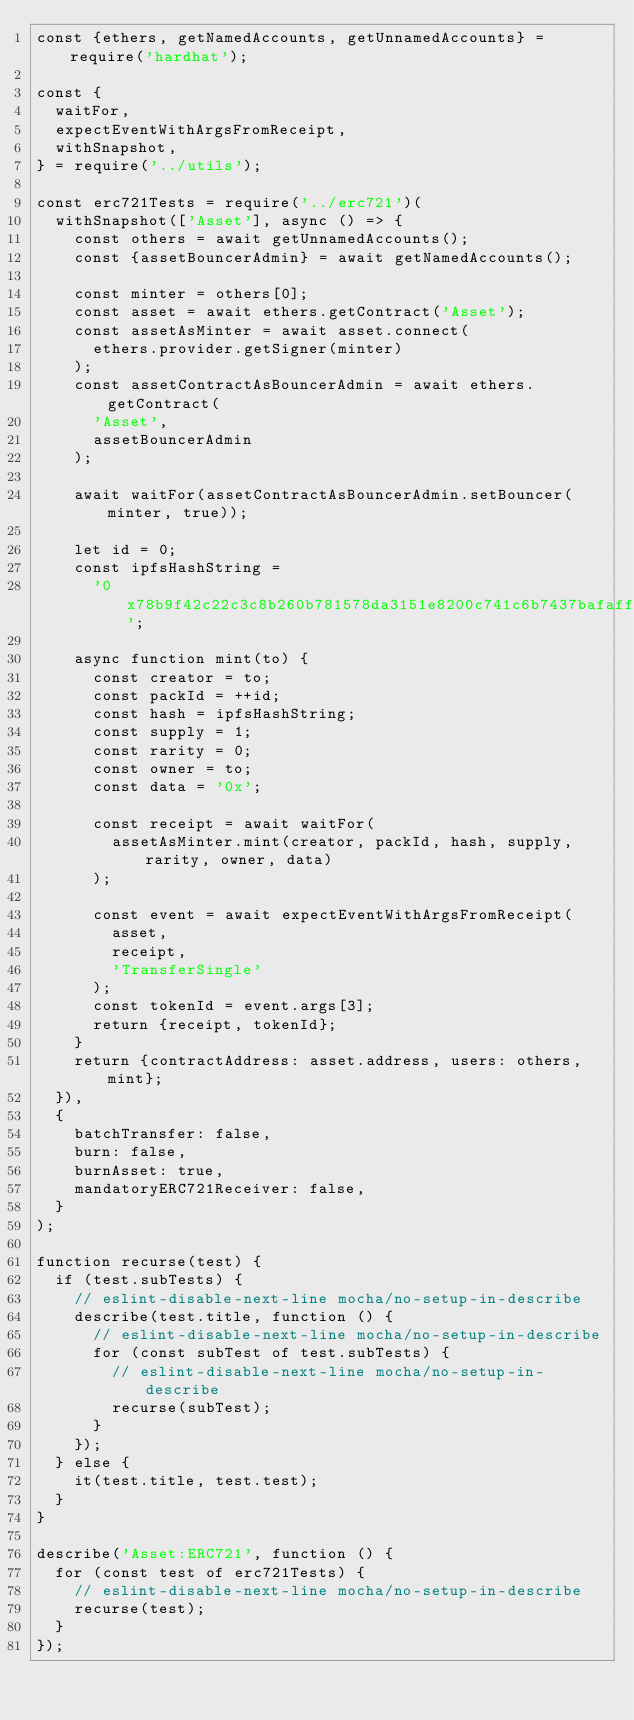<code> <loc_0><loc_0><loc_500><loc_500><_JavaScript_>const {ethers, getNamedAccounts, getUnnamedAccounts} = require('hardhat');

const {
  waitFor,
  expectEventWithArgsFromReceipt,
  withSnapshot,
} = require('../utils');

const erc721Tests = require('../erc721')(
  withSnapshot(['Asset'], async () => {
    const others = await getUnnamedAccounts();
    const {assetBouncerAdmin} = await getNamedAccounts();

    const minter = others[0];
    const asset = await ethers.getContract('Asset');
    const assetAsMinter = await asset.connect(
      ethers.provider.getSigner(minter)
    );
    const assetContractAsBouncerAdmin = await ethers.getContract(
      'Asset',
      assetBouncerAdmin
    );

    await waitFor(assetContractAsBouncerAdmin.setBouncer(minter, true));

    let id = 0;
    const ipfsHashString =
      '0x78b9f42c22c3c8b260b781578da3151e8200c741c6b7437bafaff5a9df9b403e';

    async function mint(to) {
      const creator = to;
      const packId = ++id;
      const hash = ipfsHashString;
      const supply = 1;
      const rarity = 0;
      const owner = to;
      const data = '0x';

      const receipt = await waitFor(
        assetAsMinter.mint(creator, packId, hash, supply, rarity, owner, data)
      );

      const event = await expectEventWithArgsFromReceipt(
        asset,
        receipt,
        'TransferSingle'
      );
      const tokenId = event.args[3];
      return {receipt, tokenId};
    }
    return {contractAddress: asset.address, users: others, mint};
  }),
  {
    batchTransfer: false,
    burn: false,
    burnAsset: true,
    mandatoryERC721Receiver: false,
  }
);

function recurse(test) {
  if (test.subTests) {
    // eslint-disable-next-line mocha/no-setup-in-describe
    describe(test.title, function () {
      // eslint-disable-next-line mocha/no-setup-in-describe
      for (const subTest of test.subTests) {
        // eslint-disable-next-line mocha/no-setup-in-describe
        recurse(subTest);
      }
    });
  } else {
    it(test.title, test.test);
  }
}

describe('Asset:ERC721', function () {
  for (const test of erc721Tests) {
    // eslint-disable-next-line mocha/no-setup-in-describe
    recurse(test);
  }
});
</code> 